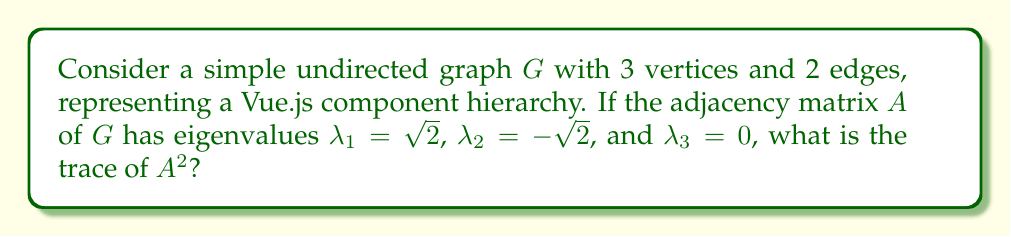Teach me how to tackle this problem. Let's approach this step-by-step:

1) The trace of a matrix is the sum of its diagonal elements. For an adjacency matrix A, the trace of $A^2$ is related to the number of walks of length 2 in the graph.

2) However, we can also calculate the trace of $A^2$ using the eigenvalues of A. This is because:

   $tr(A^2) = \sum_{i=1}^n \lambda_i^2$

   where $\lambda_i$ are the eigenvalues of A.

3) We are given the eigenvalues:
   $\lambda_1 = \sqrt{2}$
   $\lambda_2 = -\sqrt{2}$
   $\lambda_3 = 0$

4) Let's calculate $\lambda_i^2$ for each eigenvalue:
   $\lambda_1^2 = (\sqrt{2})^2 = 2$
   $\lambda_2^2 = (-\sqrt{2})^2 = 2$
   $\lambda_3^2 = 0^2 = 0$

5) Now, we sum these values:
   $tr(A^2) = \lambda_1^2 + \lambda_2^2 + \lambda_3^2 = 2 + 2 + 0 = 4$

Therefore, the trace of $A^2$ is 4.
Answer: 4 